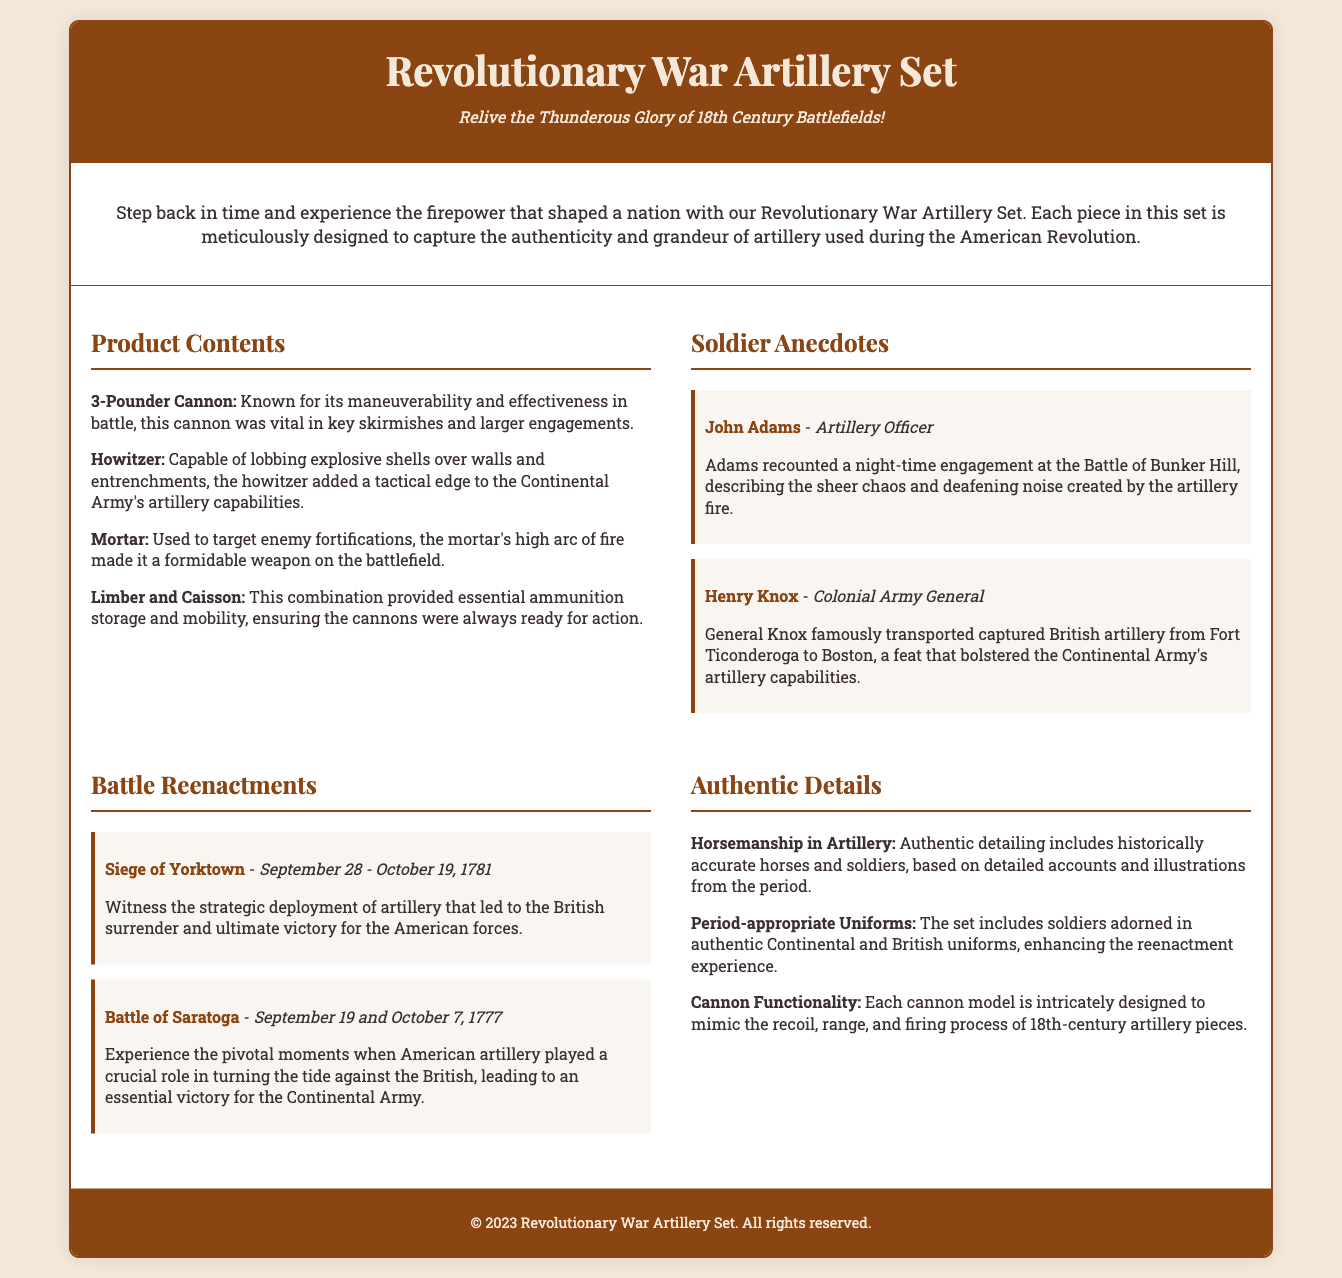what is the title of the product? The title of the product is prominently displayed at the top of the document.
Answer: Revolutionary War Artillery Set who recounted a night-time engagement at the Battle of Bunker Hill? The document includes anecdotes from specific individuals, one of whom is mentioned in Soldier Anecdotes.
Answer: John Adams what type of cannon is known for its maneuverability? The document lists different artillery pieces and describes their characteristics.
Answer: 3-Pounder Cannon which battle's artillery deployment led to the British surrender? The document outlines significant battles where artillery played a crucial role.
Answer: Siege of Yorktown who famously transported captured British artillery? The document provides anecdotes about notable figures related to artillery in the war.
Answer: Henry Knox how many cannons are included in the product contents? The document enumerates the key artillery pieces in the product offering.
Answer: Four what is one of the focuses mentioned regarding cannon functionality? The Authentic Details section discusses specific design elements of the cannons.
Answer: Mimic the recoil which uniforms are included in the set? The document highlights specific details related to soldier attire in the Authentic Details section.
Answer: Continental and British uniforms when did the Battle of Saratoga take place? The document provides dates for significant battles relevant to the product.
Answer: September 19 and October 7, 1777 